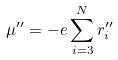<formula> <loc_0><loc_0><loc_500><loc_500>\mu ^ { \prime \prime } = - e \sum _ { i = 3 } ^ { N } r _ { i } ^ { \prime \prime }</formula> 